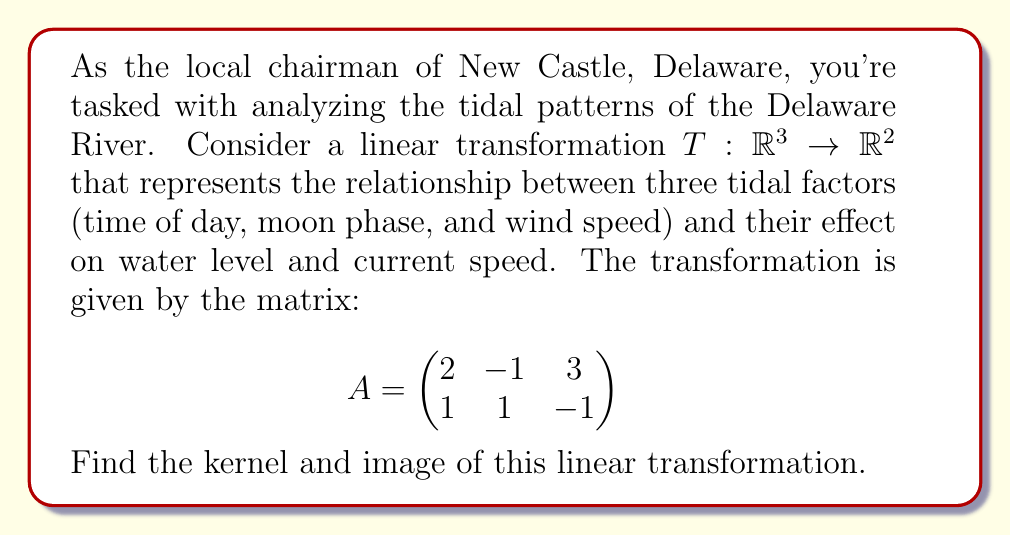Teach me how to tackle this problem. To find the kernel and image of the linear transformation $T$, we'll follow these steps:

1. Find the kernel (null space):
   The kernel consists of all vectors $\mathbf{x} \in \mathbb{R}^3$ such that $A\mathbf{x} = \mathbf{0}$.
   
   $$\begin{pmatrix}
   2 & -1 & 3 \\
   1 & 1 & -1
   \end{pmatrix} \begin{pmatrix} x \\ y \\ z \end{pmatrix} = \begin{pmatrix} 0 \\ 0 \end{pmatrix}$$

   This gives us the system of equations:
   $$\begin{cases}
   2x - y + 3z = 0 \\
   x + y - z = 0
   \end{cases}$$

   Solving this system:
   From the second equation: $x = z - y$
   Substituting into the first equation:
   $$2(z-y) - y + 3z = 0$$
   $$2z - 2y - y + 3z = 0$$
   $$5z - 3y = 0$$
   $$y = \frac{5}{3}z$$

   Therefore, the general solution is:
   $$\mathbf{x} = z\begin{pmatrix} -\frac{2}{3} \\ \frac{5}{3} \\ 1 \end{pmatrix}$$

   The kernel is the span of this vector.

2. Find the image (column space):
   The image consists of all possible outputs of the transformation. It's spanned by the columns of matrix $A$.

   $$\text{Im}(T) = \text{span}\left\{\begin{pmatrix} 2 \\ 1 \end{pmatrix}, \begin{pmatrix} -1 \\ 1 \end{pmatrix}, \begin{pmatrix} 3 \\ -1 \end{pmatrix}\right\}$$

   To find a basis for the image, we need to check for linear independence of these vectors. We can see that the third vector is a linear combination of the first two:

   $$\begin{pmatrix} 3 \\ -1 \end{pmatrix} = \frac{3}{2}\begin{pmatrix} 2 \\ 1 \end{pmatrix} + \frac{5}{2}\begin{pmatrix} -1 \\ 1 \end{pmatrix}$$

   Therefore, a basis for the image consists of the first two column vectors.
Answer: Kernel: $\text{Ker}(T) = \text{span}\left\{\begin{pmatrix} -\frac{2}{3} \\ \frac{5}{3} \\ 1 \end{pmatrix}\right\}$

Image: $\text{Im}(T) = \text{span}\left\{\begin{pmatrix} 2 \\ 1 \end{pmatrix}, \begin{pmatrix} -1 \\ 1 \end{pmatrix}\right\}$ 